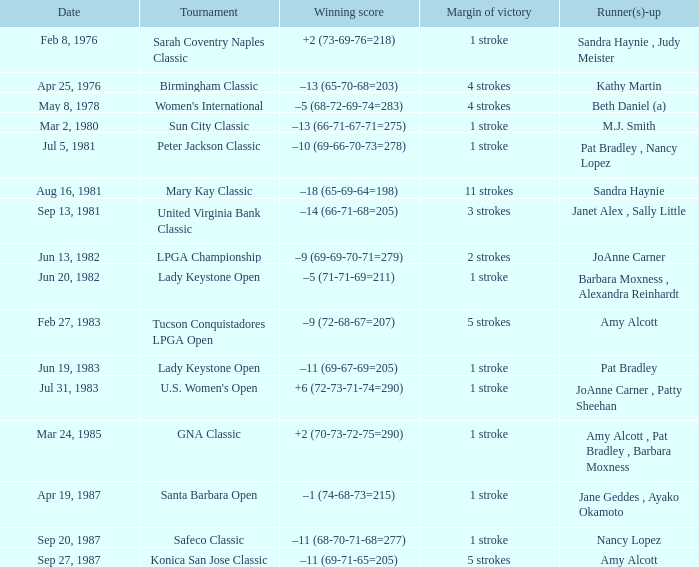What is the margin of victory when the runner-up is amy alcott and the winning score is –9 (72-68-67=207)? 5 strokes. 